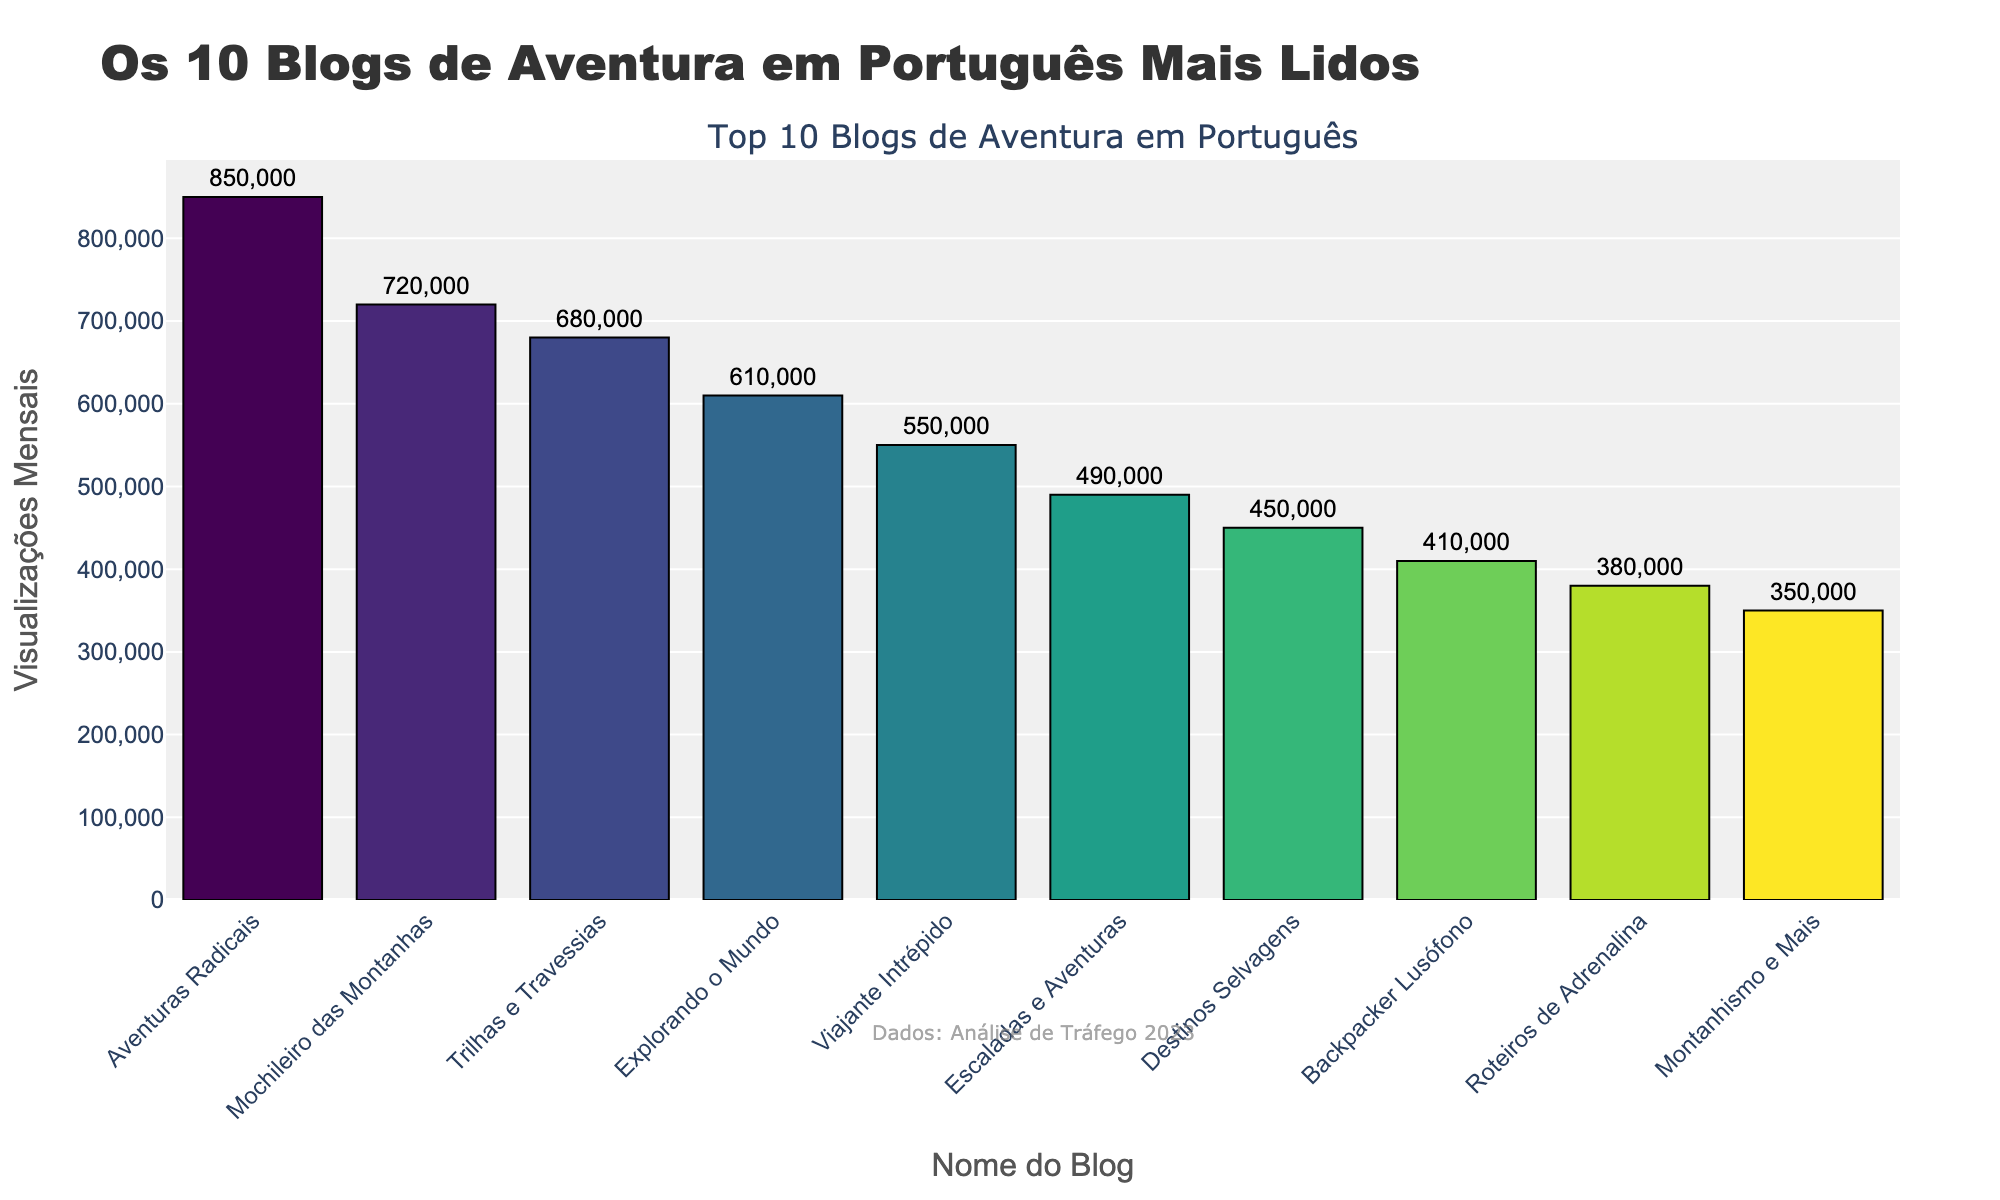Which blog has the most monthly page views? The blog with the highest bar represents the one with the most monthly page views. According to the chart, "Aventuras Radicais" has the tallest bar, indicating it has the most views.
Answer: Aventuras Radicais What is the difference in monthly page views between "Aventuras Radicais" and "Mochileiro das Montanhas"? To find the difference in monthly page views, subtract the views of "Mochileiro das Montanhas" (720,000) from "Aventuras Radicais" (850,000). The operation is 850,000 - 720,000 = 130,000
Answer: 130,000 Which blog ranks 5th in terms of monthly page views? By observing the heights of the bars in descending order, the 5th bar corresponds to "Viajante Intrépido" with 550,000 monthly page views.
Answer: Viajante Intrépido How many page views do the top 3 blogs have in total? Sum the monthly page views of the top 3 blogs: "Aventuras Radicais" (850,000), "Mochileiro das Montanhas" (720,000), and "Trilhas e Travessias" (680,000). The operation is 850,000 + 720,000 + 680,000 = 2,250,000
Answer: 2,250,000 Which two blogs have the closest number of monthly page views, and what is that difference? Compare the absolute differences between consecutive bars: for example, "Trilhas e Travessias" (680,000) and "Explorando o Mundo" (610,000). The smallest difference is between "Trilhas e Travessias" and "Explorando o Mundo": 680,000 - 610,000 = 70,000
Answer: Trilhas e Travessias and Explorando o Mundo, 70,000 How many blogs have more than 500,000 monthly page views? By counting the number of bars above the 500,000 mark, we see there are four such blogs: "Aventuras Radicais", "Mochileiro das Montanhas", "Trilhas e Travessias", and "Explorando o Mundo".
Answer: Four What is the average number of monthly page views among the top 10 blogs? Sum the views of the top 10 blogs and then divide by 10. The operation is (850,000 + 720,000 + 680,000 + 610,000 + 550,000 + 490,000 + 450,000 + 410,000 + 380,000 + 350,000) ÷ 10 = 549,000
Answer: 549,000 